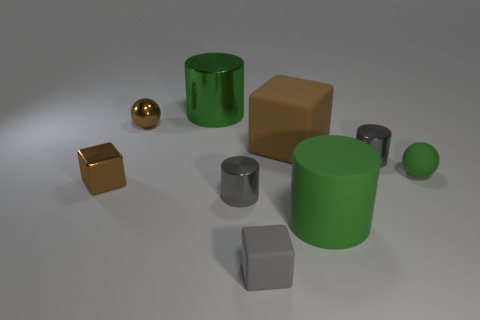What number of rubber things are yellow cubes or small cubes?
Keep it short and to the point. 1. How many big things have the same color as the metal ball?
Give a very brief answer. 1. The block behind the gray cylinder that is on the right side of the small gray matte block is made of what material?
Keep it short and to the point. Rubber. The green rubber cylinder is what size?
Offer a terse response. Large. How many gray shiny cylinders are the same size as the brown rubber cube?
Give a very brief answer. 0. How many large brown objects have the same shape as the tiny green rubber object?
Provide a succinct answer. 0. Is the number of small gray rubber blocks behind the matte cylinder the same as the number of green matte blocks?
Your response must be concise. Yes. There is a brown thing that is the same size as the matte cylinder; what is its shape?
Your answer should be very brief. Cube. Are there any small brown things of the same shape as the big green matte object?
Your answer should be very brief. No. There is a large green cylinder that is in front of the large green thing that is behind the big rubber cylinder; are there any rubber objects that are in front of it?
Give a very brief answer. Yes. 